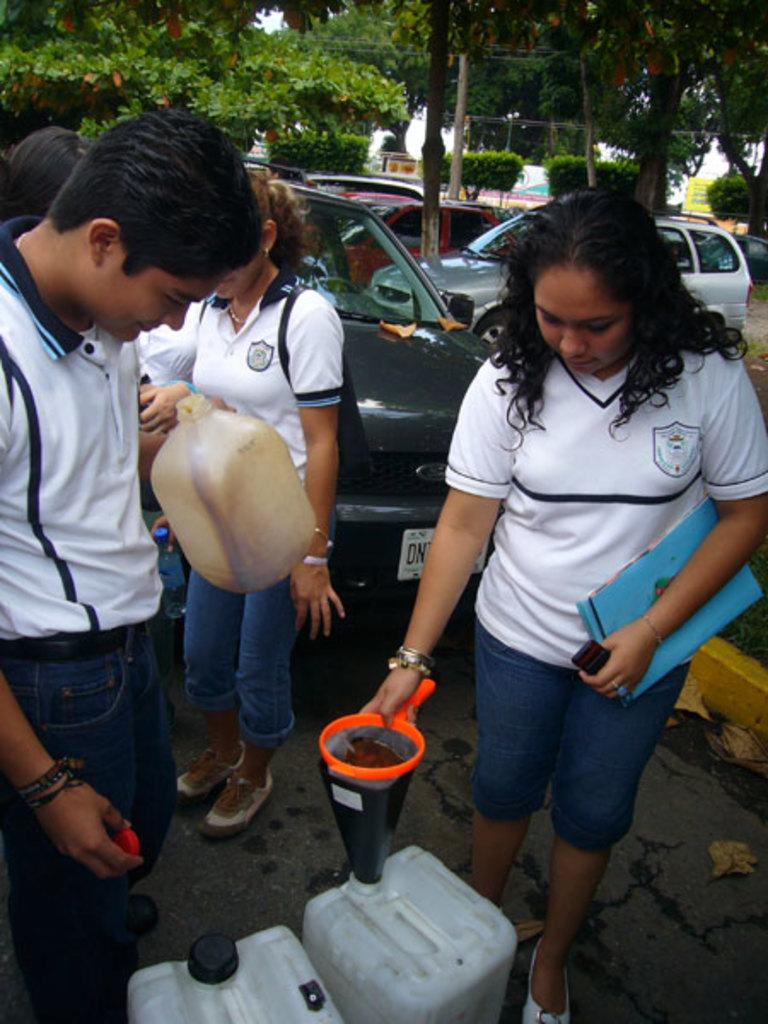What can be seen in the foreground of the image? There are people, cans, a funnel, and vehicles in the foreground of the image. What type of objects are present in the foreground? The objects in the foreground include cans and a funnel. What are the people doing in the image? The actions of the people cannot be determined from the provided facts. What is visible in the background of the image? There are trees in the background of the image. What is the layout of the image? The road is at the bottom of the image, and the sky is visible at the top of the image. How many eyes can be seen on the fowl in the image? There is no fowl present in the image, so the number of eyes cannot be determined. What type of space vehicle is visible in the image? There is no space vehicle present in the image. 